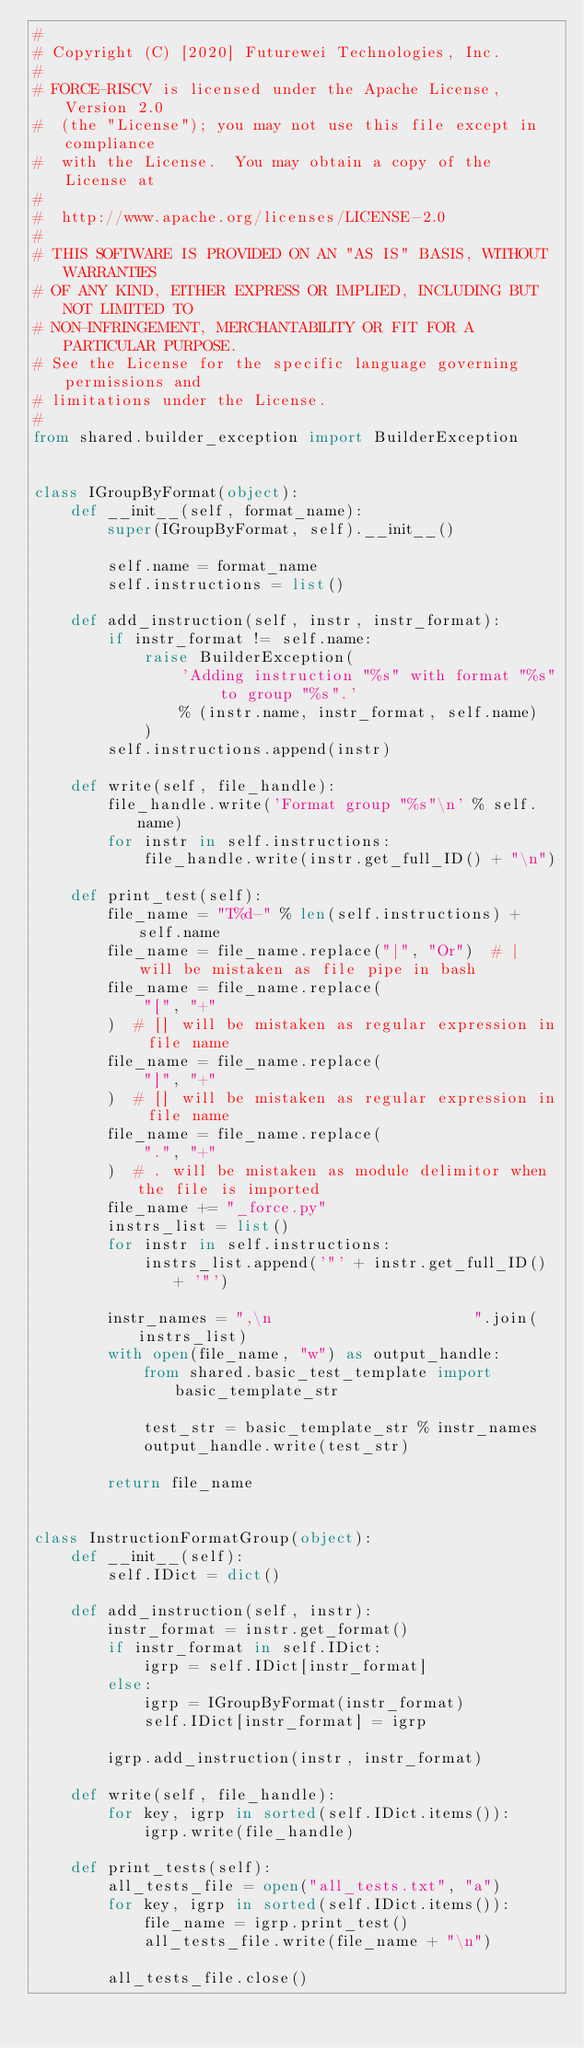<code> <loc_0><loc_0><loc_500><loc_500><_Python_>#
# Copyright (C) [2020] Futurewei Technologies, Inc.
#
# FORCE-RISCV is licensed under the Apache License, Version 2.0
#  (the "License"); you may not use this file except in compliance
#  with the License.  You may obtain a copy of the License at
#
#  http://www.apache.org/licenses/LICENSE-2.0
#
# THIS SOFTWARE IS PROVIDED ON AN "AS IS" BASIS, WITHOUT WARRANTIES
# OF ANY KIND, EITHER EXPRESS OR IMPLIED, INCLUDING BUT NOT LIMITED TO
# NON-INFRINGEMENT, MERCHANTABILITY OR FIT FOR A PARTICULAR PURPOSE.
# See the License for the specific language governing permissions and
# limitations under the License.
#
from shared.builder_exception import BuilderException


class IGroupByFormat(object):
    def __init__(self, format_name):
        super(IGroupByFormat, self).__init__()

        self.name = format_name
        self.instructions = list()

    def add_instruction(self, instr, instr_format):
        if instr_format != self.name:
            raise BuilderException(
                'Adding instruction "%s" with format "%s" to group "%s".'
                % (instr.name, instr_format, self.name)
            )
        self.instructions.append(instr)

    def write(self, file_handle):
        file_handle.write('Format group "%s"\n' % self.name)
        for instr in self.instructions:
            file_handle.write(instr.get_full_ID() + "\n")

    def print_test(self):
        file_name = "T%d-" % len(self.instructions) + self.name
        file_name = file_name.replace("|", "Or")  # | will be mistaken as file pipe in bash
        file_name = file_name.replace(
            "[", "+"
        )  # [] will be mistaken as regular expression in file name
        file_name = file_name.replace(
            "]", "+"
        )  # [] will be mistaken as regular expression in file name
        file_name = file_name.replace(
            ".", "+"
        )  # . will be mistaken as module delimitor when the file is imported
        file_name += "_force.py"
        instrs_list = list()
        for instr in self.instructions:
            instrs_list.append('"' + instr.get_full_ID() + '"')

        instr_names = ",\n                      ".join(instrs_list)
        with open(file_name, "w") as output_handle:
            from shared.basic_test_template import basic_template_str

            test_str = basic_template_str % instr_names
            output_handle.write(test_str)

        return file_name


class InstructionFormatGroup(object):
    def __init__(self):
        self.IDict = dict()

    def add_instruction(self, instr):
        instr_format = instr.get_format()
        if instr_format in self.IDict:
            igrp = self.IDict[instr_format]
        else:
            igrp = IGroupByFormat(instr_format)
            self.IDict[instr_format] = igrp

        igrp.add_instruction(instr, instr_format)

    def write(self, file_handle):
        for key, igrp in sorted(self.IDict.items()):
            igrp.write(file_handle)

    def print_tests(self):
        all_tests_file = open("all_tests.txt", "a")
        for key, igrp in sorted(self.IDict.items()):
            file_name = igrp.print_test()
            all_tests_file.write(file_name + "\n")

        all_tests_file.close()
</code> 